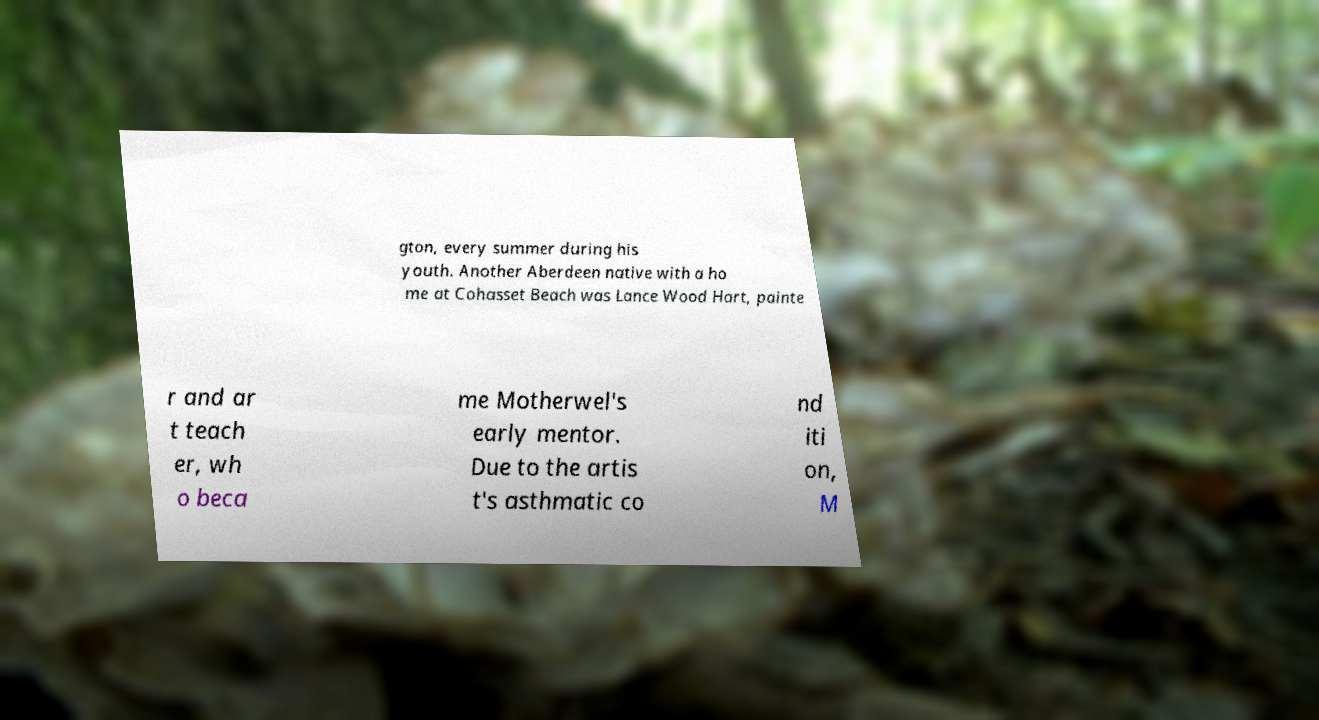I need the written content from this picture converted into text. Can you do that? gton, every summer during his youth. Another Aberdeen native with a ho me at Cohasset Beach was Lance Wood Hart, painte r and ar t teach er, wh o beca me Motherwel's early mentor. Due to the artis t's asthmatic co nd iti on, M 